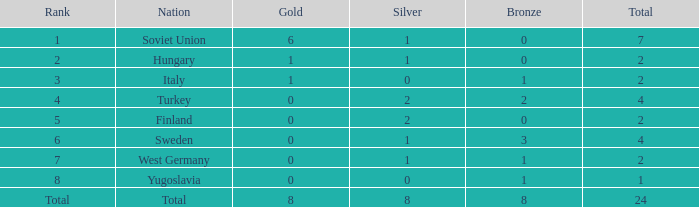Could you parse the entire table? {'header': ['Rank', 'Nation', 'Gold', 'Silver', 'Bronze', 'Total'], 'rows': [['1', 'Soviet Union', '6', '1', '0', '7'], ['2', 'Hungary', '1', '1', '0', '2'], ['3', 'Italy', '1', '0', '1', '2'], ['4', 'Turkey', '0', '2', '2', '4'], ['5', 'Finland', '0', '2', '0', '2'], ['6', 'Sweden', '0', '1', '3', '4'], ['7', 'West Germany', '0', '1', '1', '2'], ['8', 'Yugoslavia', '0', '0', '1', '1'], ['Total', 'Total', '8', '8', '8', '24']]} What is the sum of Total, when Rank is 8, and when Bronze is less than 1? None. 